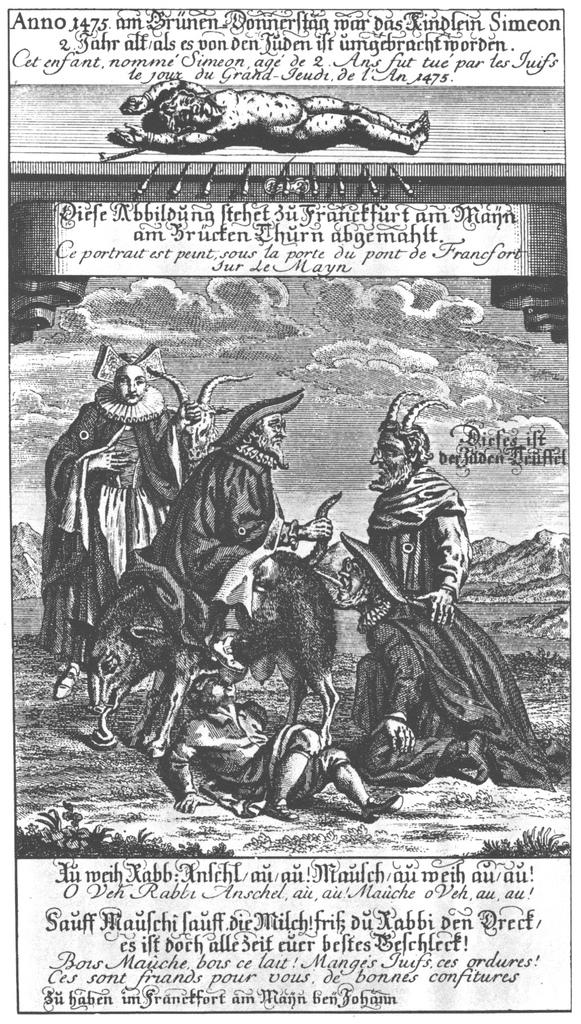How many people are in the image? There are persons in the image, but the exact number is not specified. What can be seen above the persons in the image? There is text written above the persons in the image. What can be seen below the persons in the image? There is text written below the persons in the image. What direction are the persons in the image looking? The direction in which the persons are looking is not mentioned in the facts, so it cannot be determined from the image. 